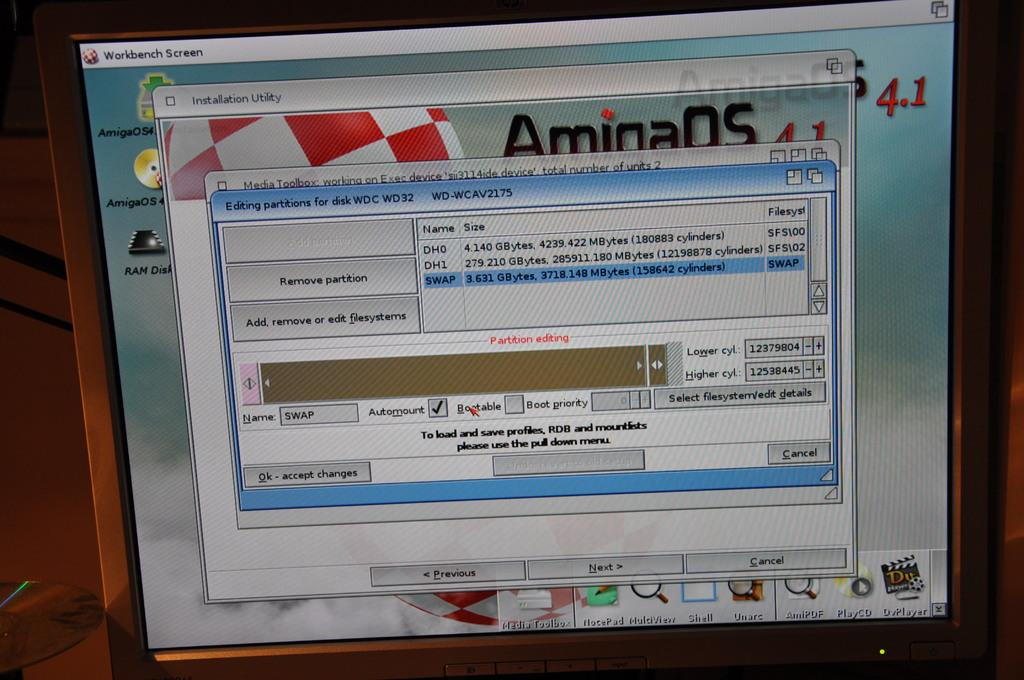<image>
Offer a succinct explanation of the picture presented. a computer screen that has the tab WorkBench open 